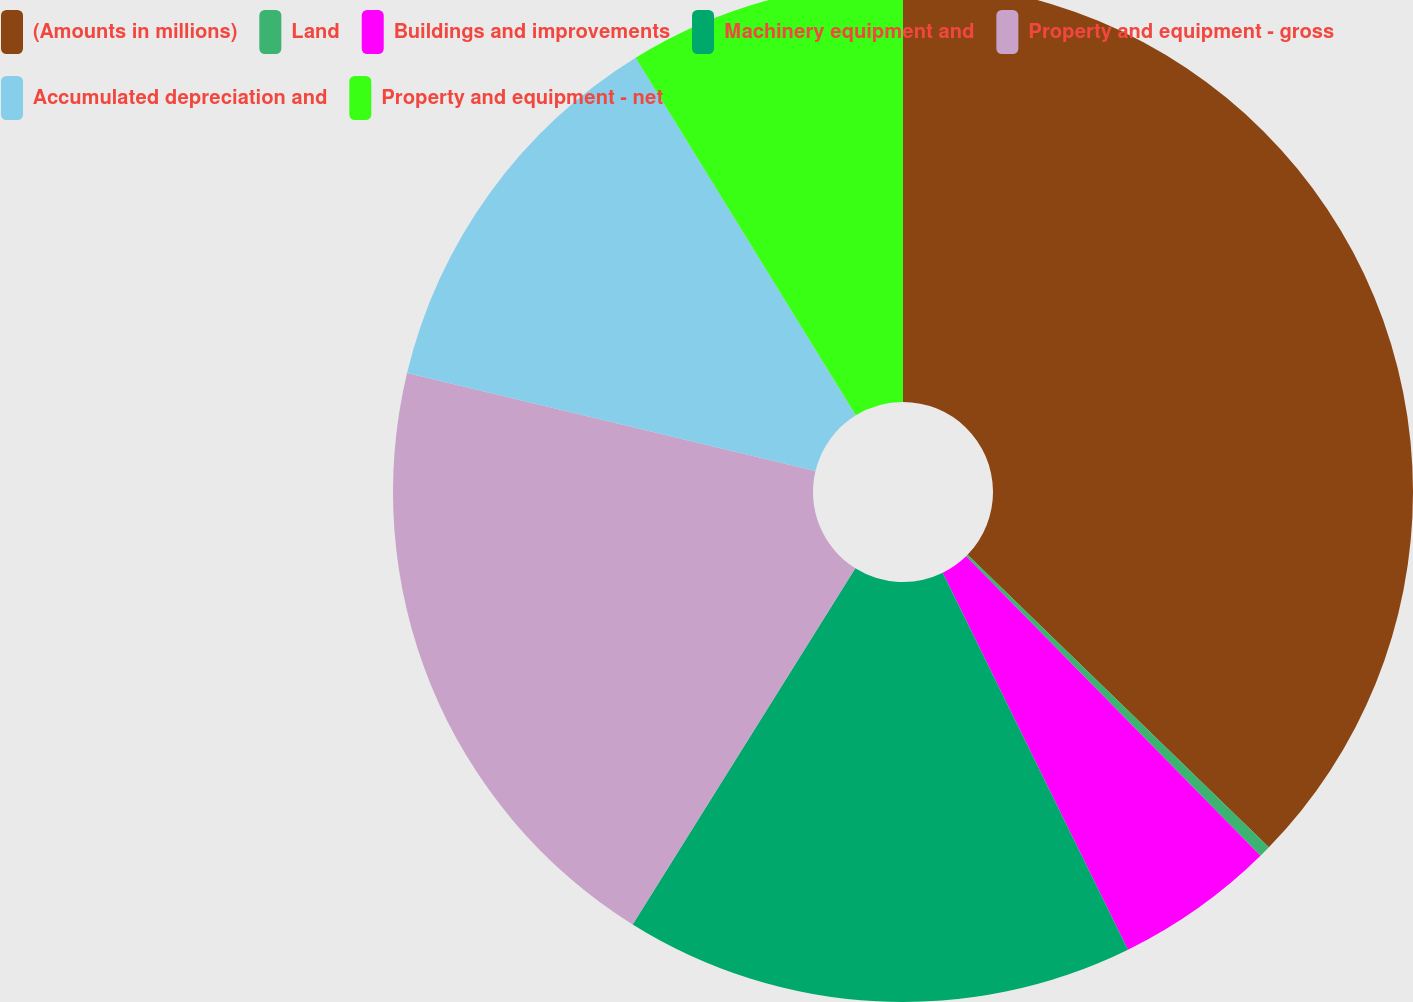Convert chart to OTSL. <chart><loc_0><loc_0><loc_500><loc_500><pie_chart><fcel>(Amounts in millions)<fcel>Land<fcel>Buildings and improvements<fcel>Machinery equipment and<fcel>Property and equipment - gross<fcel>Accumulated depreciation and<fcel>Property and equipment - net<nl><fcel>37.26%<fcel>0.37%<fcel>5.09%<fcel>16.16%<fcel>19.85%<fcel>12.47%<fcel>8.78%<nl></chart> 